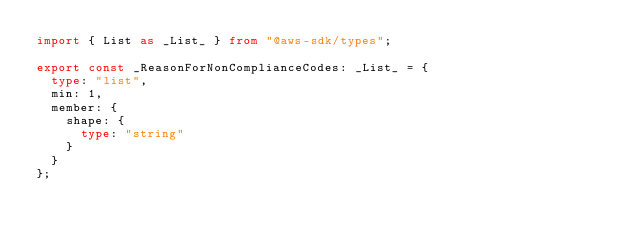Convert code to text. <code><loc_0><loc_0><loc_500><loc_500><_TypeScript_>import { List as _List_ } from "@aws-sdk/types";

export const _ReasonForNonComplianceCodes: _List_ = {
  type: "list",
  min: 1,
  member: {
    shape: {
      type: "string"
    }
  }
};
</code> 